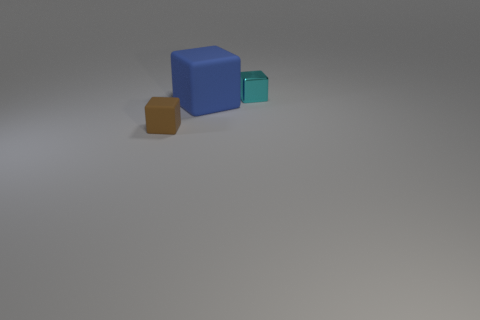Is there any other thing that is the same size as the blue rubber thing?
Make the answer very short. No. Does the blue cube have the same material as the tiny object that is right of the blue rubber cube?
Your response must be concise. No. What is the material of the cube that is both in front of the cyan thing and behind the small rubber block?
Keep it short and to the point. Rubber. What color is the small object that is behind the tiny thing left of the cyan object?
Keep it short and to the point. Cyan. There is a tiny object right of the blue thing; what is its material?
Provide a succinct answer. Metal. Is the number of small cyan things less than the number of objects?
Provide a succinct answer. Yes. Is the shape of the small matte object the same as the thing behind the big blue matte cube?
Provide a short and direct response. Yes. What is the shape of the object that is on the right side of the brown thing and in front of the tiny cyan metallic block?
Your answer should be compact. Cube. Are there an equal number of metallic cubes to the right of the big blue rubber thing and brown rubber blocks that are to the right of the cyan metal block?
Offer a very short reply. No. How many green things are either tiny things or rubber cubes?
Provide a succinct answer. 0. 